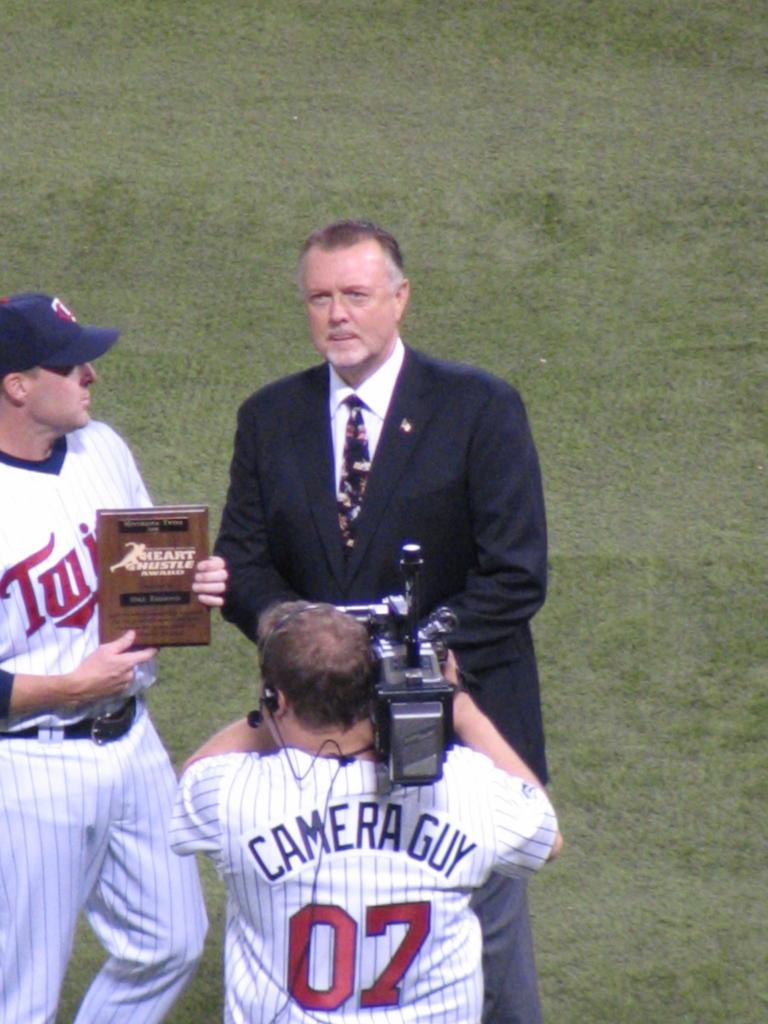<image>
Summarize the visual content of the image. a man with a camera and the number 07 on his back 